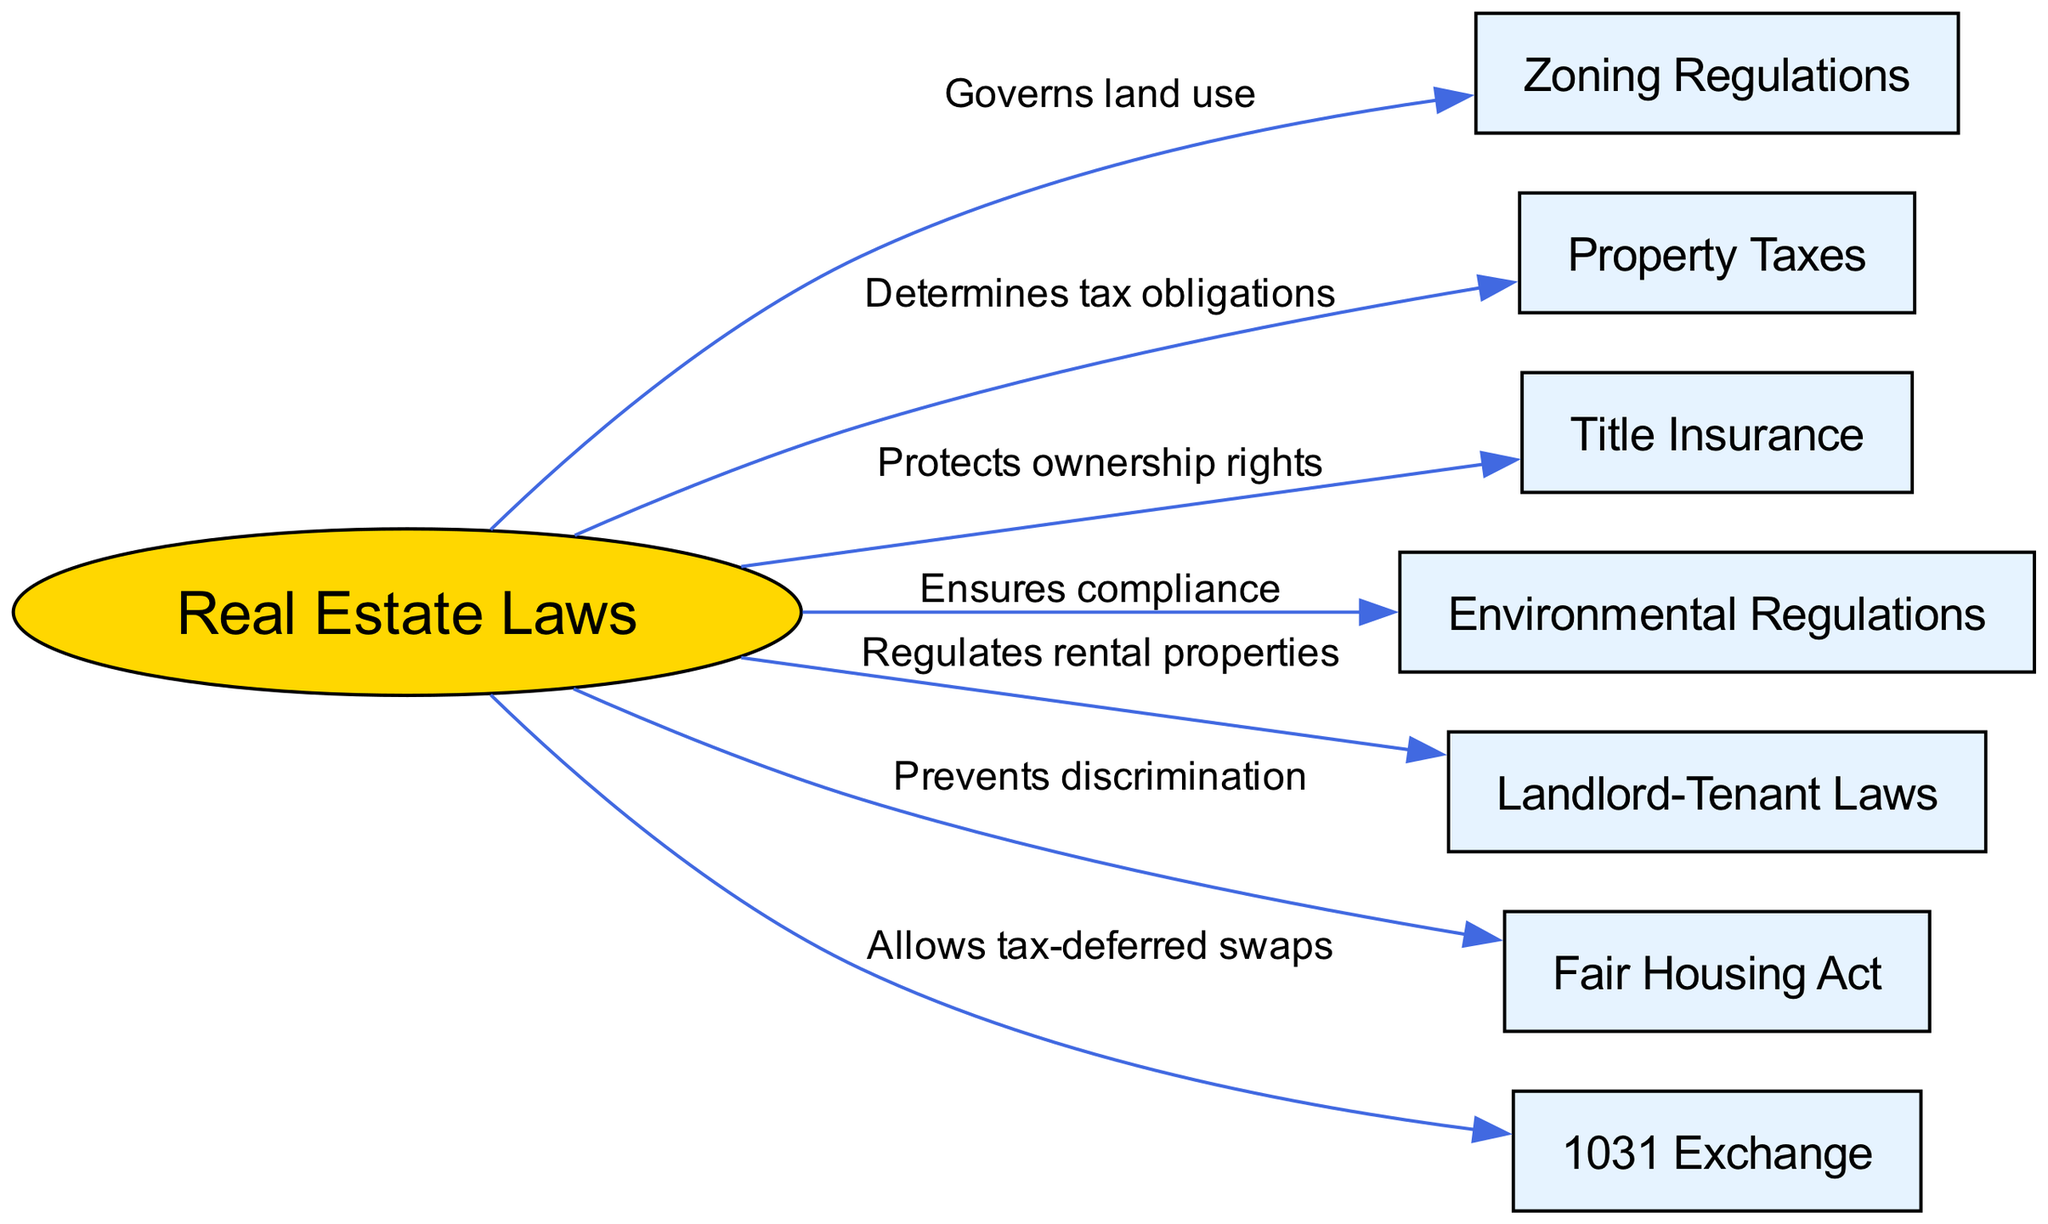what is the total number of nodes in the diagram? The diagram includes a total of 8 nodes, which correspond to various aspects of real estate laws mentioned in the data.
Answer: 8 what is the relationship between real estate laws and zoning regulations? The edge connecting these two nodes indicates that real estate laws govern land use, establishing how zoning regulations fit into the broader legal framework of real estate.
Answer: Governs land use which law prevents discrimination in housing? According to the diagram, the Fair Housing Act specifically addresses discriminatory practices in housing, making it the law that prevents discrimination.
Answer: Fair Housing Act how many edges are connected to real estate laws? Real estate laws have six outgoing edges connecting to zoning regulations, property taxes, title insurance, environmental regulations, landlord-tenant laws, and the Fair Housing Act, indicating its various functions.
Answer: 6 what does the 1031 exchange allow? The diagram states that the 1031 exchange allows tax-deferred swaps, facilitating investment reinvestment without immediate tax liabilities.
Answer: Tax-deferred swaps which law regulates rental properties? The diagram specifies that landlord-tenant laws are responsible for regulating rental properties, indicating their role in maintaining the landlord-tenant relationship.
Answer: Landlord-Tenant Laws how do property taxes relate to real estate laws? The edge indicates that property taxes are determined by real estate laws, highlighting the legal basis for the imposition and regulation of taxes on properties.
Answer: Determines tax obligations what ensures compliance with environmental standards? Environmental regulations are shown in the diagram as the mechanism that ensures compliance with environmental standards in real estate transactions.
Answer: Environmental Regulations what is the nature of the relationship between real estate laws and title insurance? The diagram indicates that title insurance protects ownership rights, reflecting its importance in legal transactions related to property ownership.
Answer: Protects ownership rights 